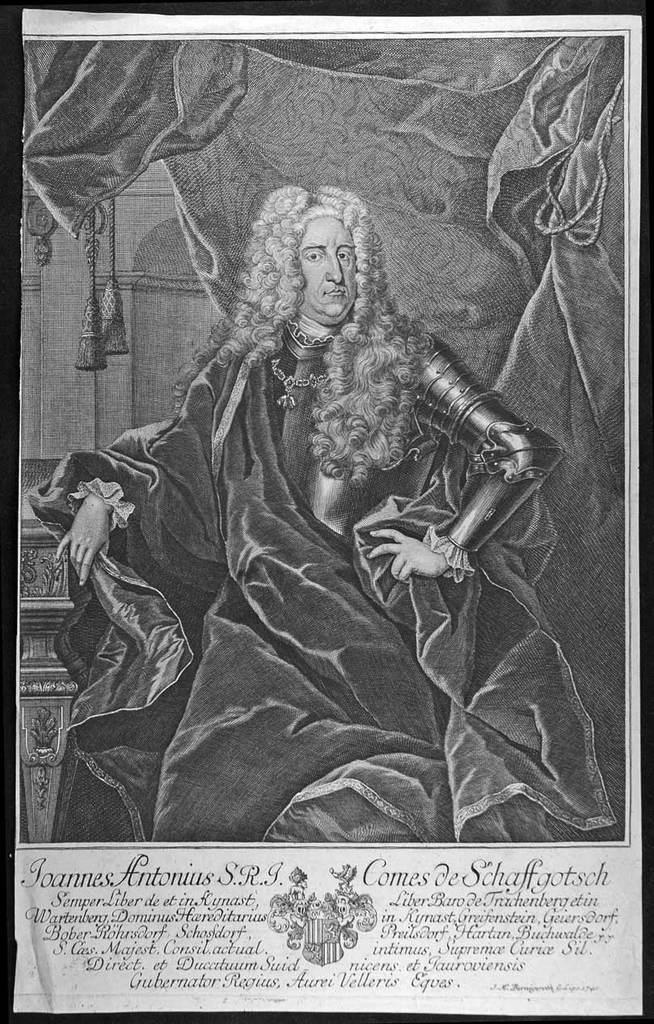Please provide a concise description of this image. This is a poster and in this poster we can see a person sitting, clothes and some text. 